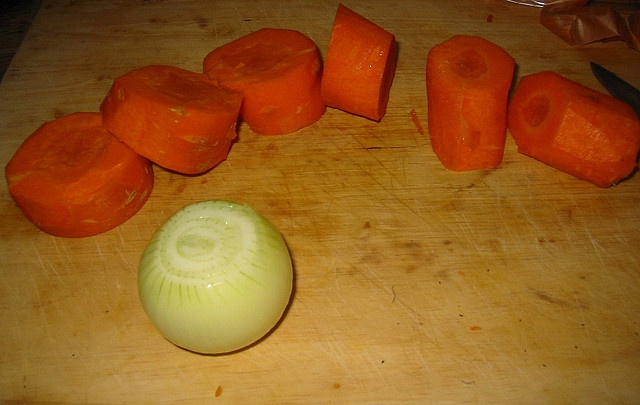Describe the objects in this image and their specific colors. I can see carrot in black, maroon, and brown tones, carrot in black, maroon, and brown tones, carrot in black, maroon, and brown tones, carrot in black, brown, and maroon tones, and carrot in black, brown, maroon, and red tones in this image. 